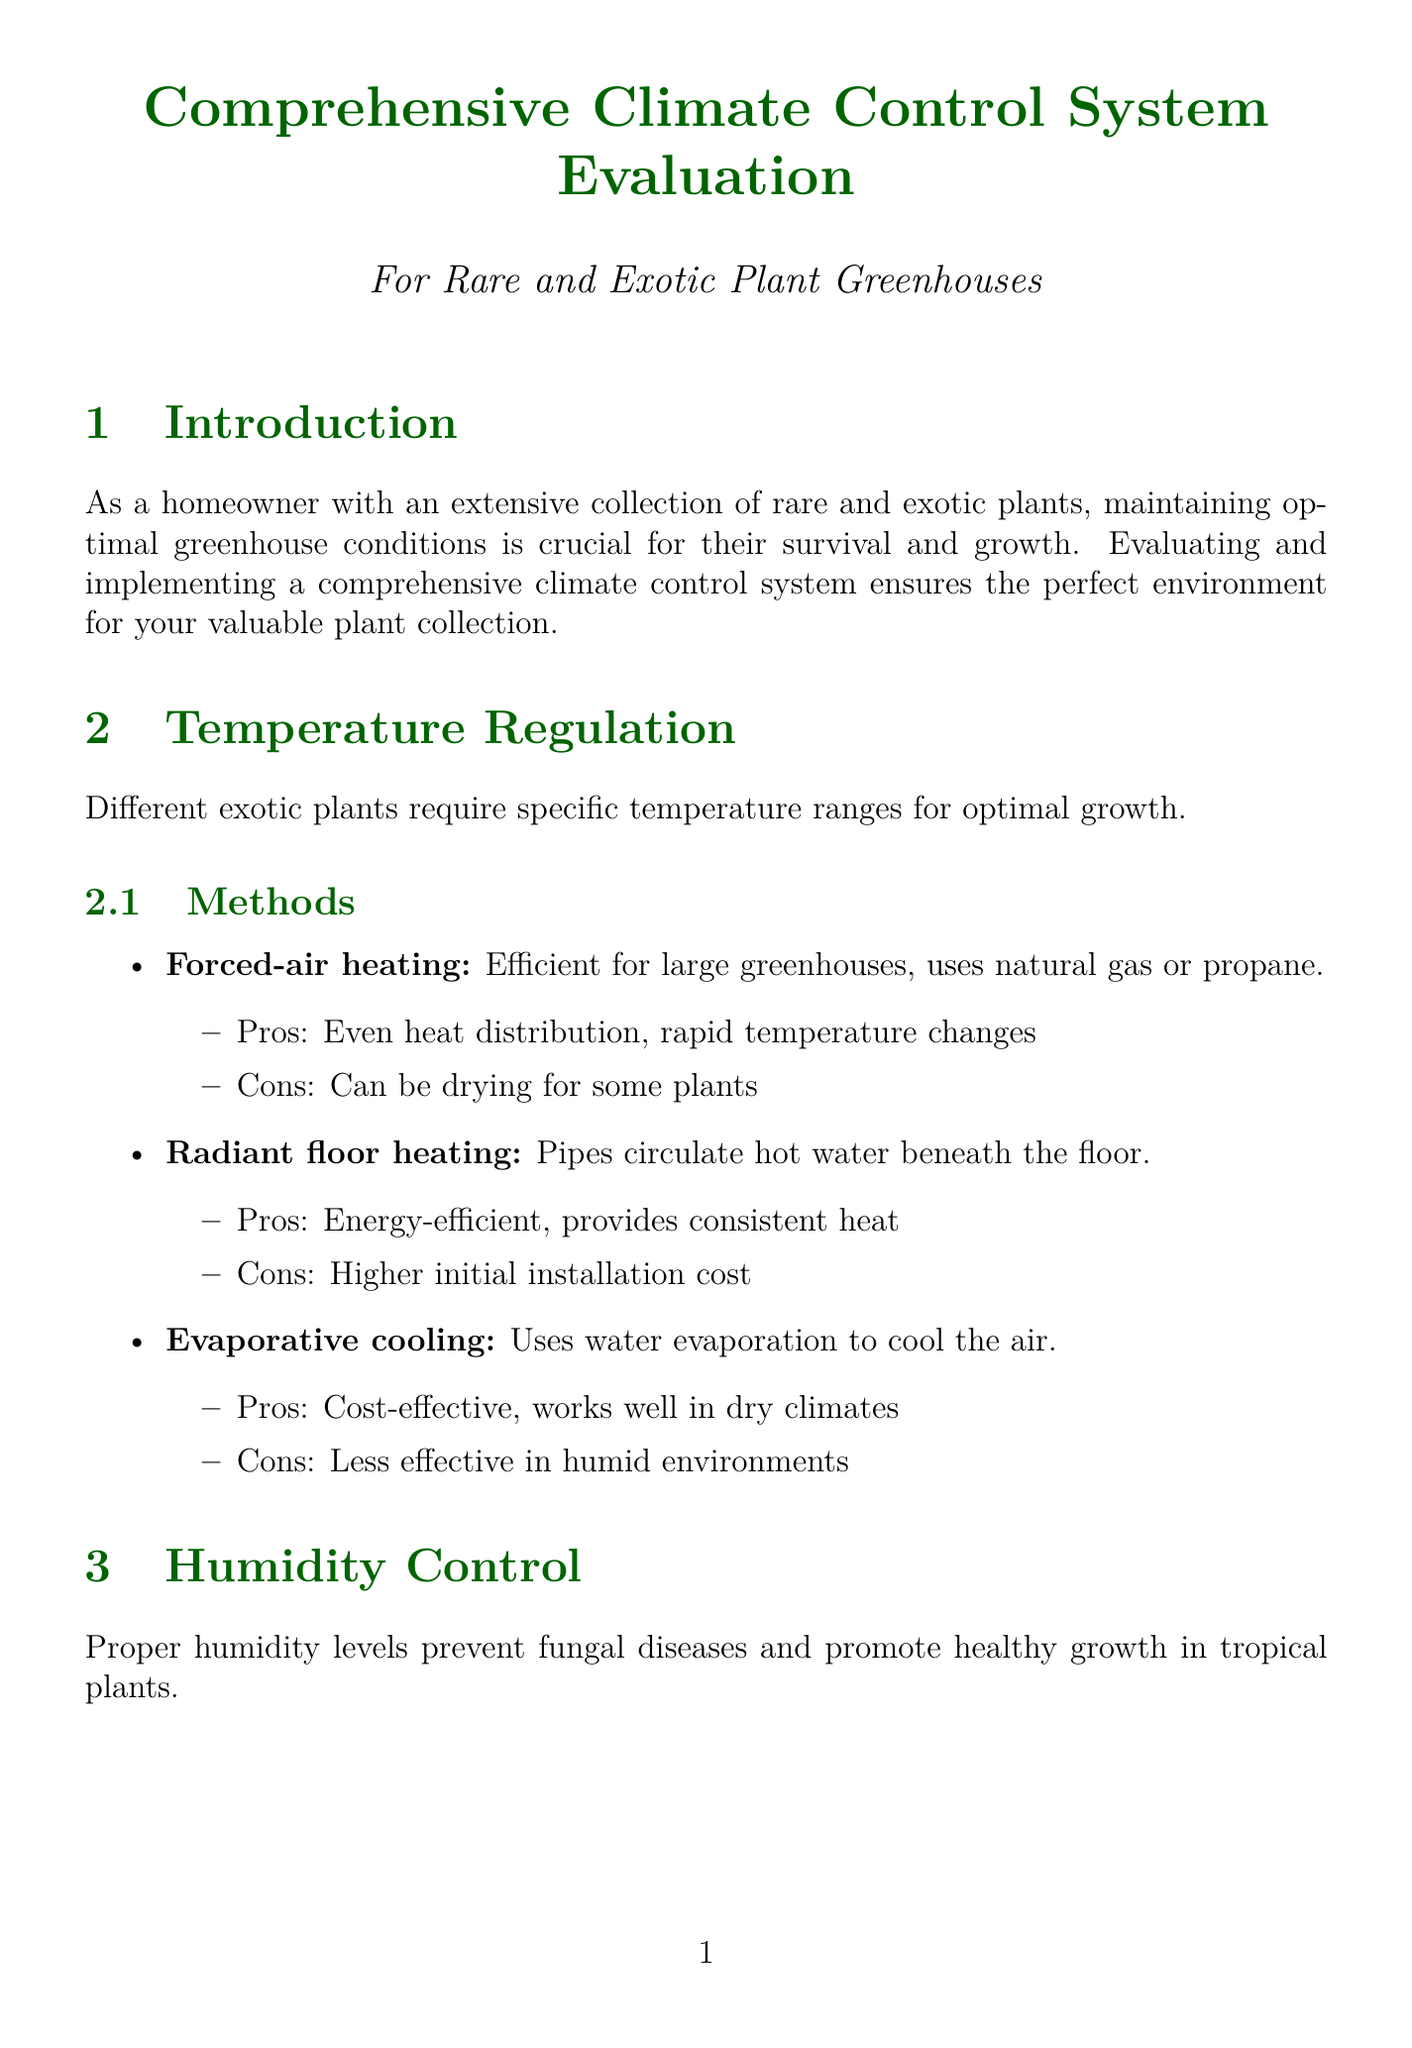What is the purpose of the report? The purpose of the report is to evaluate and implement a comprehensive climate control system to ensure the perfect environment for your valuable plant collection.
Answer: To evaluate and implement a comprehensive climate control system What type of heating uses natural gas or propane? Forced-air heating is the method that uses natural gas or propane for efficient heating in large greenhouses.
Answer: Forced-air heating What humidity range is required for Nepenthes rajah? The required humidity range for Nepenthes rajah is between 70-80%.
Answer: 70-80% What is a common issue related to excessive humidity? A common issue related to excessive humidity is fungal growth.
Answer: Fungal growth Which strategy can reduce operating costs? Using thermal screens to retain heat at night is a strategy that can reduce operating costs.
Answer: Thermal screens What are the features of Argus Controls? The features of Argus Controls include real-time monitoring, remote access via smartphone, and integration with various sensors and equipment.
Answer: Real-time monitoring, remote access via smartphone, integration with various sensors and equipment What type of ventilation mimics natural conditions? Natural ventilation is the type that mimics natural conditions.
Answer: Natural ventilation Which heating method is energy-efficient but has a higher initial cost? Radiant floor heating is energy-efficient but has a higher initial installation cost.
Answer: Radiant floor heating 